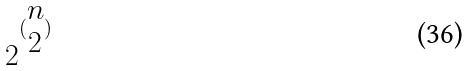Convert formula to latex. <formula><loc_0><loc_0><loc_500><loc_500>2 ^ { ( \begin{matrix} n \\ 2 \end{matrix} ) }</formula> 